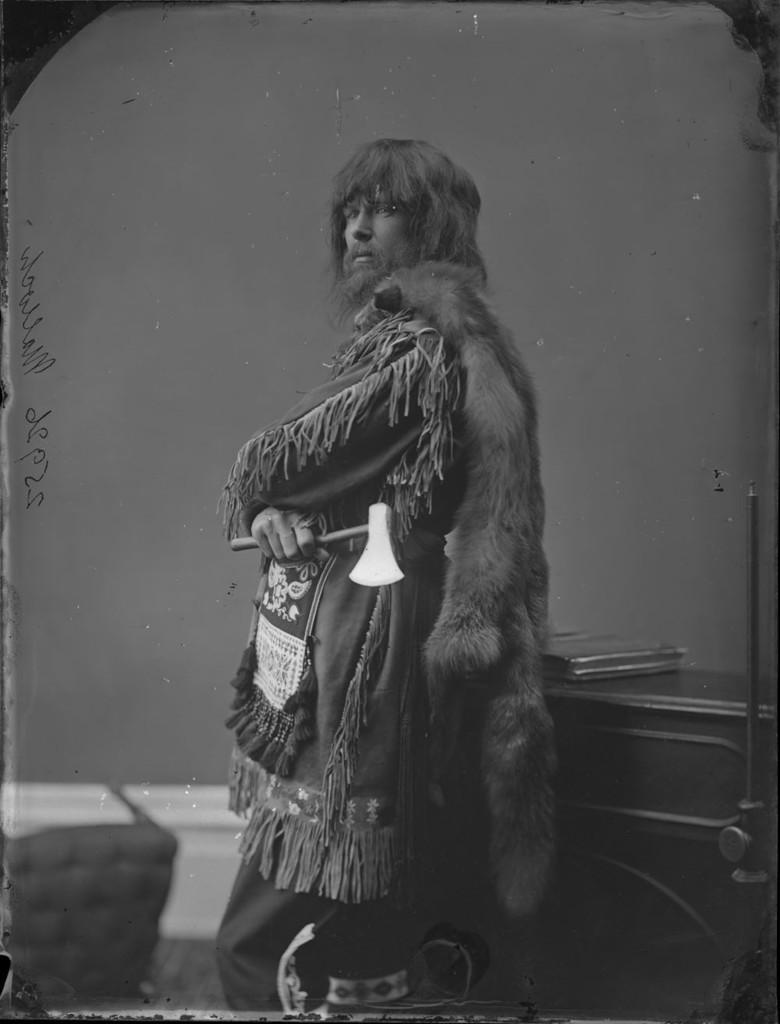Please provide a concise description of this image. In this image a man is standing in front of a cabinet. He is holding an axe. Here there is a chair. This is the wall. 